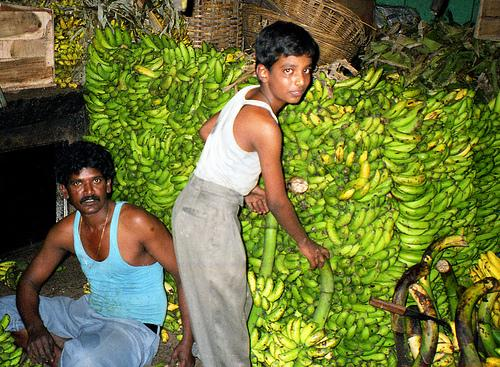Can you spot any fruit in the image? If yes, what is it, and where is it located? Yes, there are bananas in the image. Multiple instances are located at different X and Y coordinates. Enumerate the colors of the bananas described in the image. The bananas are green. Provide the total number of green bananas visible in the image. There are 13 instances of green bananas in the image. Analyze the sentiment of the image based on the captions. The sentiment is neutral as it mostly describes objects, clothes, and people in the scene. Identify the clothing items mentioned in the image, as well as their corresponding positions or edges. There is a part of a trouser, edge of a trouser, part of a jeans, part of a vest, and edge of a vest. List down the types of objects detected on the floor of the image. There is a part of a floor, a stack of wicker baskets, and a handle. What are the young boy and man doing in the image? The young boy is standing up, and the man is sitting down. Mention any object interactions that can be observed in the image. The man is sitting down, possibly interacting with the young boy who is standing up. 